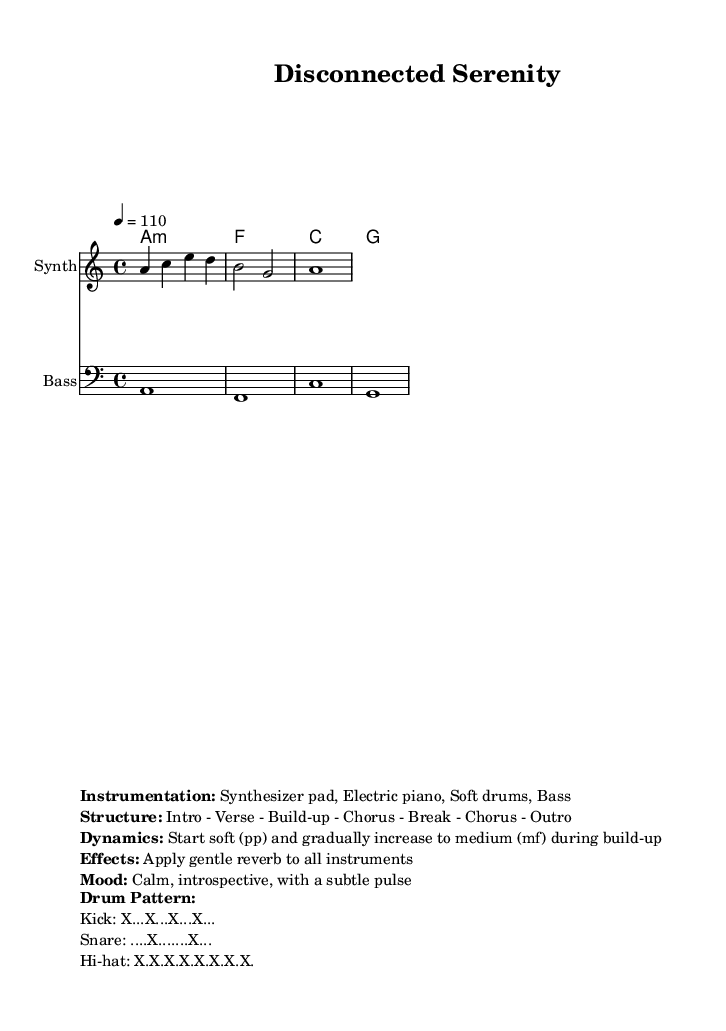What is the key signature of this music? The key signature is identified as "a minor" because it is indicated at the beginning of the score. The notation specifies that there are no sharps or flats besides what is characteristic of this key.
Answer: a minor What is the time signature? The time signature is found at the beginning of the score, shown as "4/4". This means there are four beats in each measure, and the quarter note gets one beat.
Answer: 4/4 What is the tempo marking for the piece? The tempo is indicated in the score as "4 = 110". This means the piece should be played at 110 beats per minute, equivalent to a moderate tempo setting.
Answer: 110 How many measures are in the melody section? Counting the measures in the melody line yields a total of three measures: the first measure has four beats, the second has two beats, and the third has one whole note, amounting to three separate measures.
Answer: 3 What is the mood described in the markup? The mood is specified in the markup as "Calm, introspective, with a subtle pulse". This describes the intended emotional character of the piece, emphasizing tranquility and reflective qualities.
Answer: Calm, introspective Which instruments are indicated in the instrumentation? The instrumentation includes a "Synthesizer pad", "Electric piano", "Soft drums", and "Bass". This provides insight into the sound palette intended for the performance of the piece.
Answer: Synthesizer pad, Electric piano, Soft drums, Bass What is the dynamic marking at the start of the piece? The dynamic marking indicates "Start soft (pp)", which signifies that the piece should begin at a very soft volume level. This affects the overall expressiveness and approach to the performance of the piece.
Answer: pp 